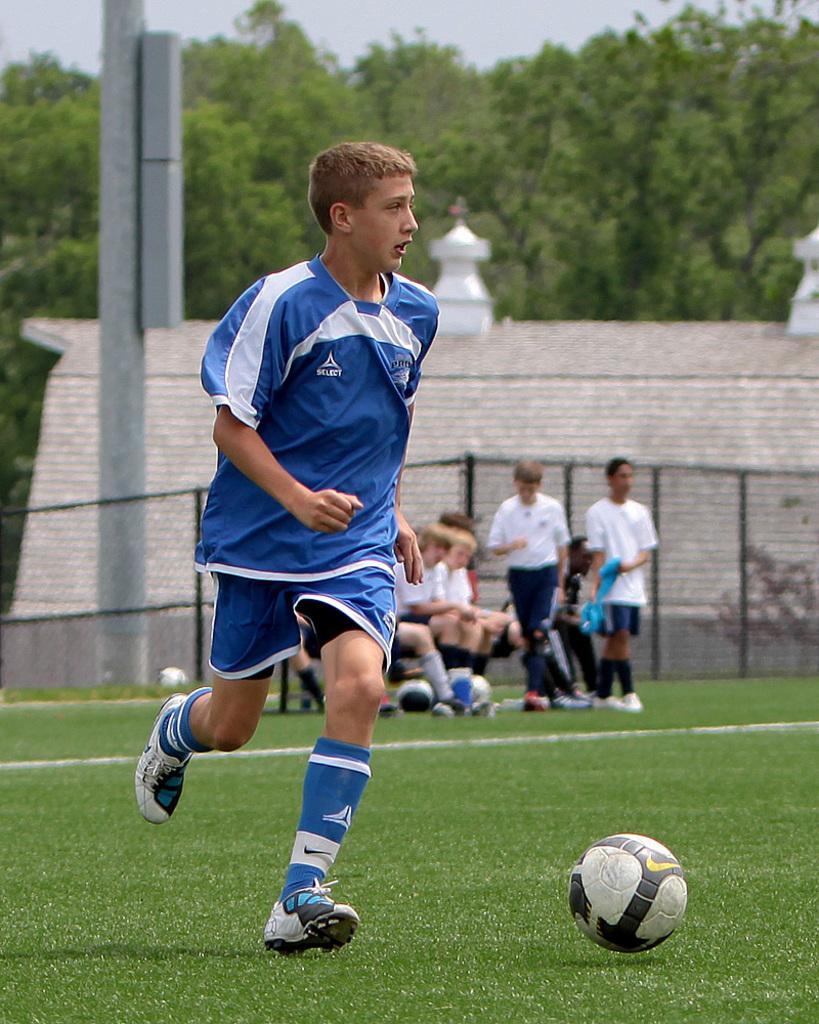Could you give a brief overview of what you see in this image? In the center of the image a boy is running. In the background of the image we can see a wall, mesh, pole and some persons are there. At the top of the image we can see some trees, sky are there. At the bottom of the image ground and ball are present. 